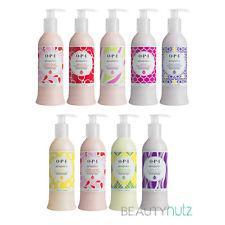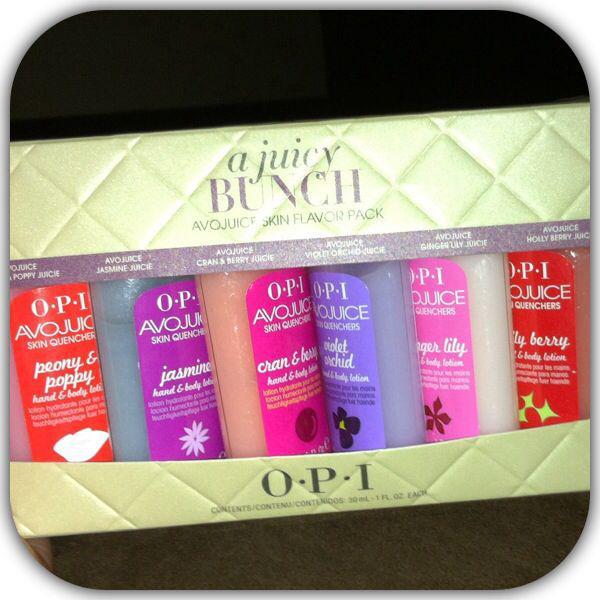The first image is the image on the left, the second image is the image on the right. For the images shown, is this caption "The left image features a single pump-top product." true? Answer yes or no. No. The first image is the image on the left, the second image is the image on the right. Assess this claim about the two images: "At least four bottles of lotion are in one image, while the other image has just one pump bottle of lotion.". Correct or not? Answer yes or no. No. 